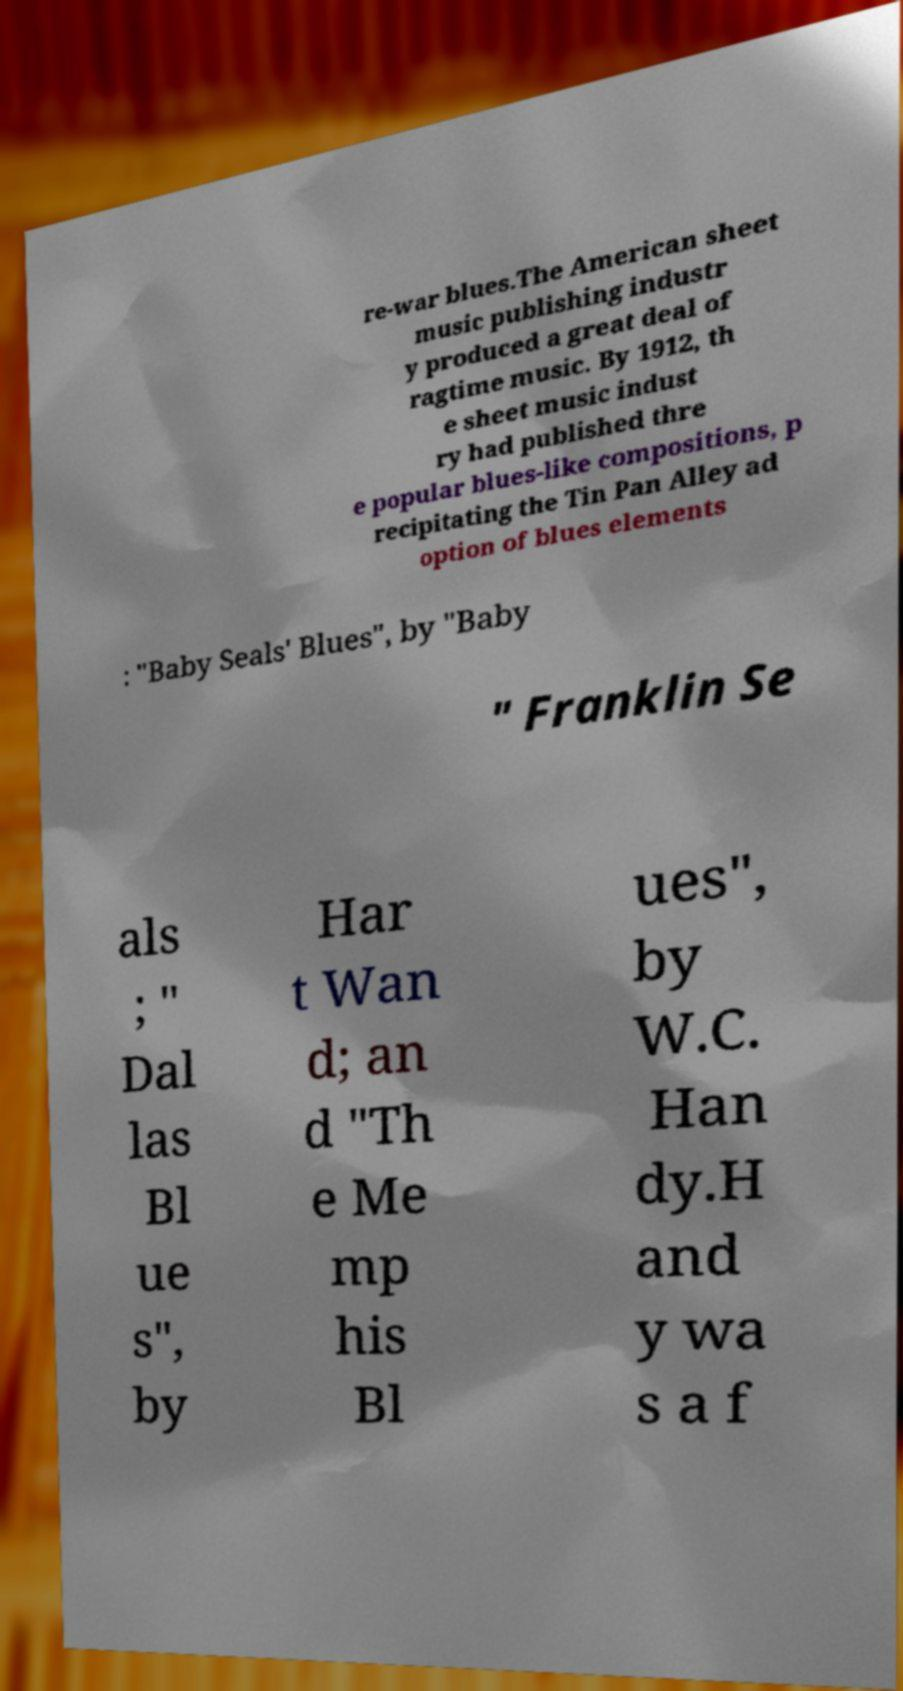Can you read and provide the text displayed in the image?This photo seems to have some interesting text. Can you extract and type it out for me? re-war blues.The American sheet music publishing industr y produced a great deal of ragtime music. By 1912, th e sheet music indust ry had published thre e popular blues-like compositions, p recipitating the Tin Pan Alley ad option of blues elements : "Baby Seals' Blues", by "Baby " Franklin Se als ; " Dal las Bl ue s", by Har t Wan d; an d "Th e Me mp his Bl ues", by W.C. Han dy.H and y wa s a f 